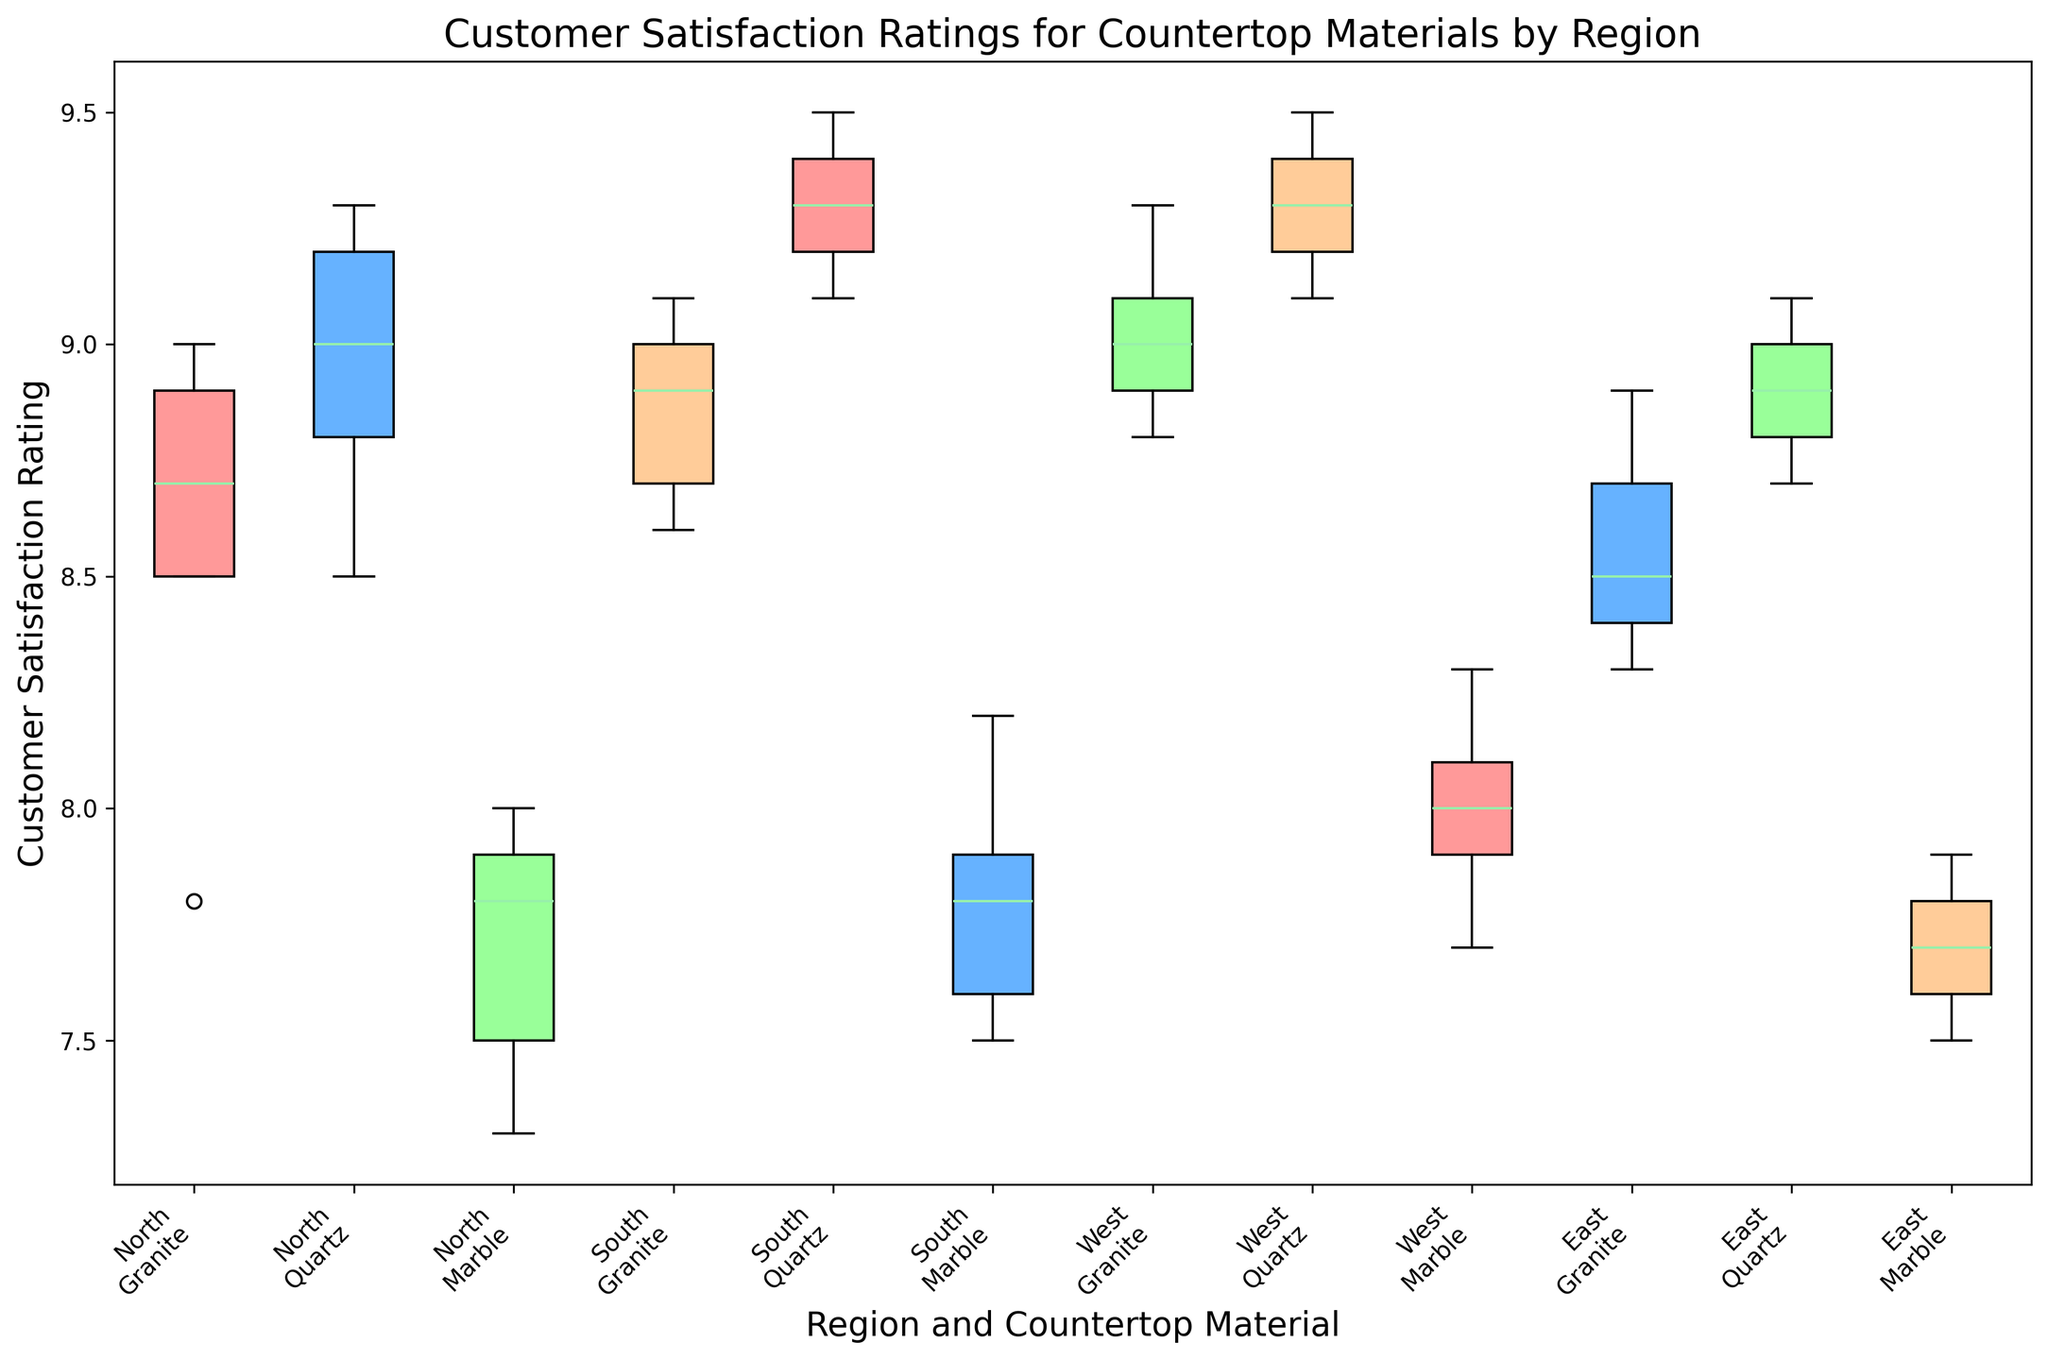Which region has the highest median customer satisfaction rating for granite? Observe the median lines (center lines) for the boxplots corresponding to granite in each region and compare them. The West region has the highest median line.
Answer: West What is the range of customer satisfaction ratings for marble in the North region? Look at the boxplot for marble in the North region, find the minimum and maximum values (whiskers). The range is from 7.3 to 8.0.
Answer: 7.3 to 8.0 Which region has the most consistent customer satisfaction ratings for quartz? Consistency can be gauged by the length of the interquartile range (IQR); the smaller the IQR, the more consistent. The East region has the smallest IQR for quartz.
Answer: East Which countertop material generally has higher customer satisfaction ratings across regions, marble or quartz? Assess the positions of the medians (lines within the boxes) for marble and quartz across all regions. Quartz has consistently higher medians than marble.
Answer: Quartz How does the median customer satisfaction rating for marble in the South compare to the other regions? Compare the median lines for marble across all regions to see where the South stands. The South has one of the higher median ratings for marble, but not the very highest.
Answer: Higher in South than most regions What is the interquartile range (IQR) for granite in the North region? Determine the range by looking at the distance between the 25th percentile (bottom of the box) and the 75th percentile (top of the box) for granite in the North region. The IQR spans from roughly 8.5 to 8.9.
Answer: 8.5 to 8.9 How does customer satisfaction for granite compare between the North and South regions? Compare the positions of the entire boxes for granite in the North and South. The South has slightly higher median and overall ratings for granite than the North.
Answer: Higher in South Which color denotes the customer satisfaction ratings for quartz in the West region? Identify the colors of the boxplots corresponding to quartz in the West region. The color for quartz in the West is blue.
Answer: Blue Based on the figure, if a client wants the highest satisfaction for their countertop material, which region and material combination would you recommend? Look for the maximum median value across all region and material combinations. Quartz in the West has the highest median satisfaction ratings.
Answer: Quartz in West Are there any noticeable outliers in the customer satisfaction ratings for any countertop materials by region? Check for any points outside the whiskers for each boxplot. There are no noticeable outliers in any of the boxplots.
Answer: No 